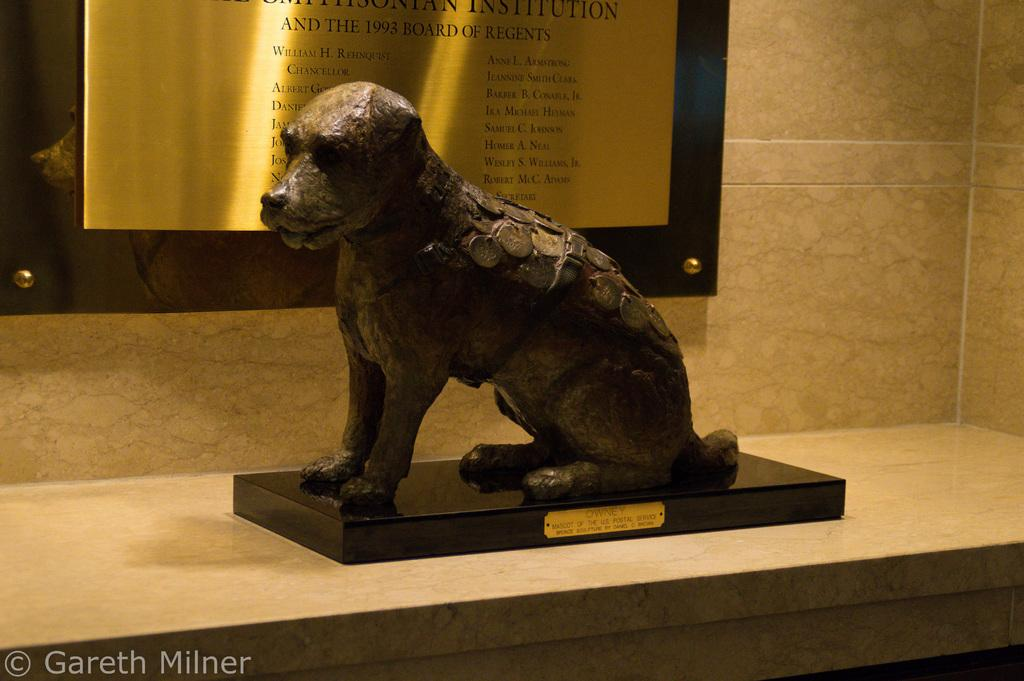What is on the table in the image? There is an animal sculpture on the table. What is on the wall in the image? There is a bronze board on the wall. What is written or depicted on the bronze board? The bronze board has some note on it. Can you describe the stretch of the animal sculpture in the image? The animal sculpture is not a living creature, so it cannot stretch. 